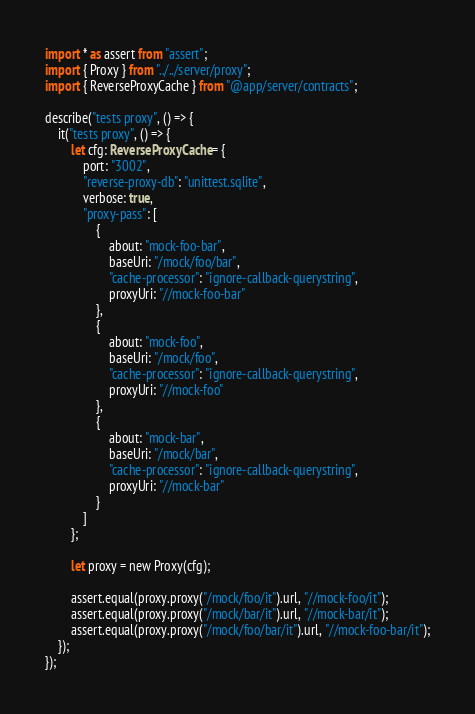Convert code to text. <code><loc_0><loc_0><loc_500><loc_500><_TypeScript_>import * as assert from "assert";
import { Proxy } from "../../server/proxy";
import { ReverseProxyCache } from "@app/server/contracts";

describe("tests proxy", () => {
    it("tests proxy", () => {
        let cfg: ReverseProxyCache = {
            port: "3002",
            "reverse-proxy-db": "unittest.sqlite",
            verbose: true,
            "proxy-pass": [
                {
                    about: "mock-foo-bar",
                    baseUri: "/mock/foo/bar",
                    "cache-processor": "ignore-callback-querystring",
                    proxyUri: "//mock-foo-bar"
                },
                {
                    about: "mock-foo",
                    baseUri: "/mock/foo",
                    "cache-processor": "ignore-callback-querystring",
                    proxyUri: "//mock-foo"
                },
                {
                    about: "mock-bar",
                    baseUri: "/mock/bar",
                    "cache-processor": "ignore-callback-querystring",
                    proxyUri: "//mock-bar"
                }
            ]
        };

        let proxy = new Proxy(cfg);

        assert.equal(proxy.proxy("/mock/foo/it").url, "//mock-foo/it");
        assert.equal(proxy.proxy("/mock/bar/it").url, "//mock-bar/it");
        assert.equal(proxy.proxy("/mock/foo/bar/it").url, "//mock-foo-bar/it");
    });
});
</code> 